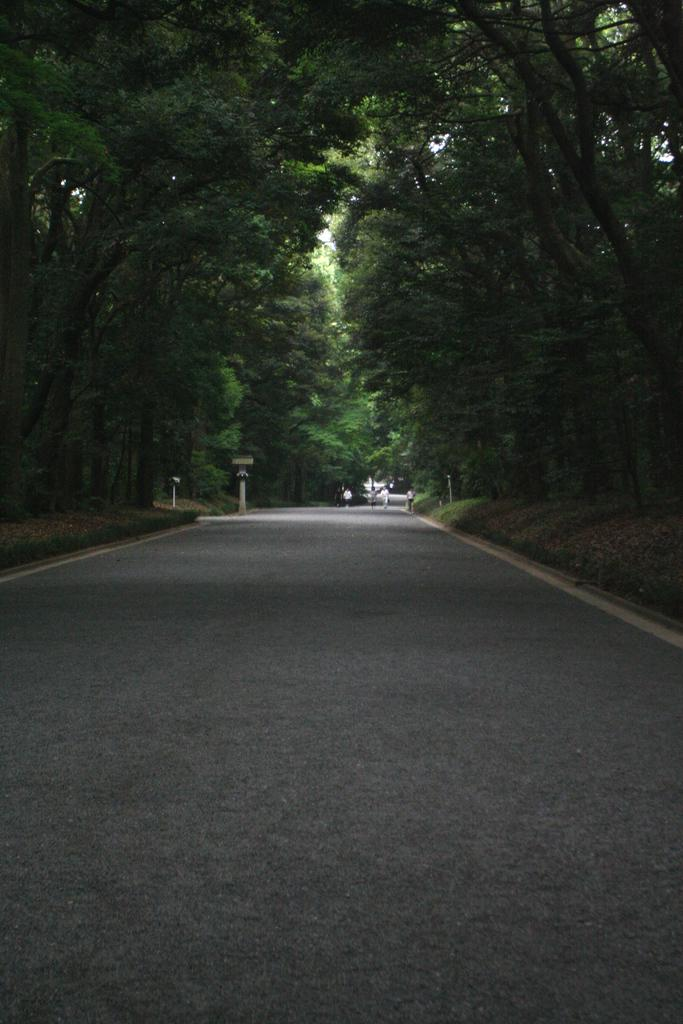Where was the image taken? The image was taken on a road. What can be seen on either side of the road? There are trees and poles visible on either side of the road. What type of vegetation is present along the road? Grass is present on the ground along the road. What type of guitar is being played in the image? There is no guitar present in the image; it is taken on a road with trees, poles, and grass. 